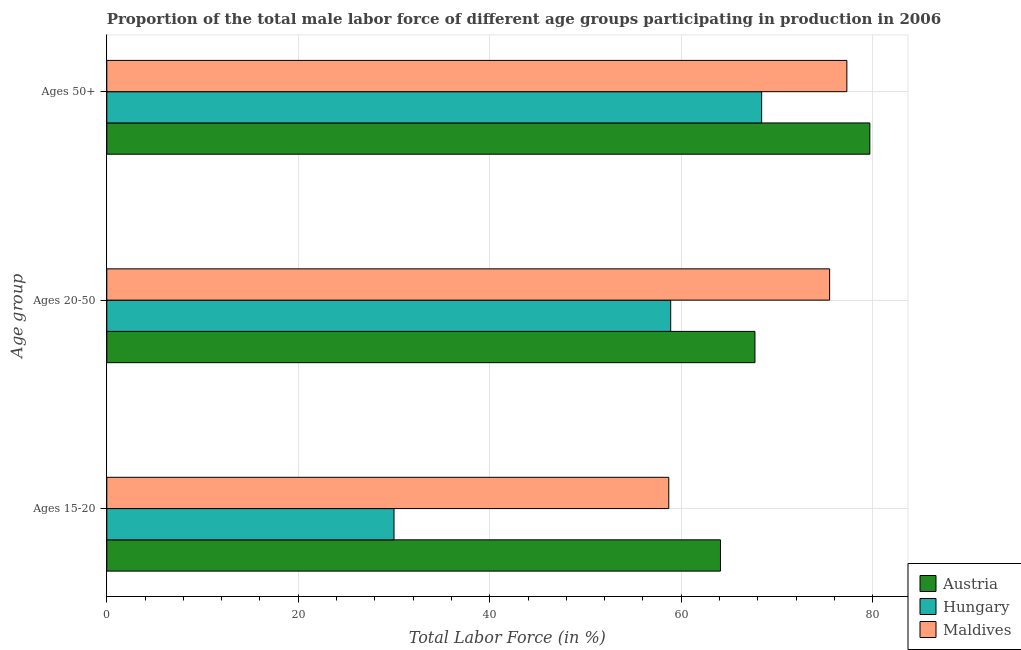How many different coloured bars are there?
Keep it short and to the point. 3. How many groups of bars are there?
Ensure brevity in your answer.  3. Are the number of bars per tick equal to the number of legend labels?
Keep it short and to the point. Yes. How many bars are there on the 1st tick from the top?
Offer a terse response. 3. How many bars are there on the 3rd tick from the bottom?
Offer a terse response. 3. What is the label of the 2nd group of bars from the top?
Provide a succinct answer. Ages 20-50. What is the percentage of male labor force within the age group 15-20 in Austria?
Offer a very short reply. 64.1. Across all countries, what is the maximum percentage of male labor force within the age group 15-20?
Keep it short and to the point. 64.1. Across all countries, what is the minimum percentage of male labor force within the age group 20-50?
Your answer should be very brief. 58.9. In which country was the percentage of male labor force within the age group 20-50 maximum?
Give a very brief answer. Maldives. In which country was the percentage of male labor force within the age group 20-50 minimum?
Ensure brevity in your answer.  Hungary. What is the total percentage of male labor force above age 50 in the graph?
Your answer should be very brief. 225.4. What is the difference between the percentage of male labor force within the age group 15-20 in Maldives and that in Hungary?
Your response must be concise. 28.7. What is the difference between the percentage of male labor force above age 50 in Hungary and the percentage of male labor force within the age group 15-20 in Austria?
Make the answer very short. 4.3. What is the average percentage of male labor force within the age group 15-20 per country?
Keep it short and to the point. 50.93. What is the difference between the percentage of male labor force within the age group 20-50 and percentage of male labor force above age 50 in Hungary?
Your answer should be compact. -9.5. In how many countries, is the percentage of male labor force within the age group 20-50 greater than 72 %?
Ensure brevity in your answer.  1. What is the ratio of the percentage of male labor force above age 50 in Maldives to that in Hungary?
Your answer should be very brief. 1.13. What is the difference between the highest and the second highest percentage of male labor force within the age group 15-20?
Offer a terse response. 5.4. What is the difference between the highest and the lowest percentage of male labor force above age 50?
Make the answer very short. 11.3. In how many countries, is the percentage of male labor force above age 50 greater than the average percentage of male labor force above age 50 taken over all countries?
Offer a terse response. 2. Is the sum of the percentage of male labor force within the age group 20-50 in Hungary and Austria greater than the maximum percentage of male labor force above age 50 across all countries?
Ensure brevity in your answer.  Yes. What does the 1st bar from the top in Ages 15-20 represents?
Provide a short and direct response. Maldives. What does the 3rd bar from the bottom in Ages 15-20 represents?
Offer a very short reply. Maldives. Does the graph contain grids?
Your response must be concise. Yes. How are the legend labels stacked?
Ensure brevity in your answer.  Vertical. What is the title of the graph?
Give a very brief answer. Proportion of the total male labor force of different age groups participating in production in 2006. Does "Liberia" appear as one of the legend labels in the graph?
Provide a succinct answer. No. What is the label or title of the Y-axis?
Offer a terse response. Age group. What is the Total Labor Force (in %) in Austria in Ages 15-20?
Offer a very short reply. 64.1. What is the Total Labor Force (in %) in Hungary in Ages 15-20?
Make the answer very short. 30. What is the Total Labor Force (in %) in Maldives in Ages 15-20?
Offer a very short reply. 58.7. What is the Total Labor Force (in %) in Austria in Ages 20-50?
Provide a succinct answer. 67.7. What is the Total Labor Force (in %) in Hungary in Ages 20-50?
Your response must be concise. 58.9. What is the Total Labor Force (in %) in Maldives in Ages 20-50?
Offer a very short reply. 75.5. What is the Total Labor Force (in %) of Austria in Ages 50+?
Make the answer very short. 79.7. What is the Total Labor Force (in %) in Hungary in Ages 50+?
Provide a short and direct response. 68.4. What is the Total Labor Force (in %) in Maldives in Ages 50+?
Ensure brevity in your answer.  77.3. Across all Age group, what is the maximum Total Labor Force (in %) of Austria?
Provide a succinct answer. 79.7. Across all Age group, what is the maximum Total Labor Force (in %) of Hungary?
Your answer should be very brief. 68.4. Across all Age group, what is the maximum Total Labor Force (in %) in Maldives?
Provide a short and direct response. 77.3. Across all Age group, what is the minimum Total Labor Force (in %) in Austria?
Your response must be concise. 64.1. Across all Age group, what is the minimum Total Labor Force (in %) of Maldives?
Keep it short and to the point. 58.7. What is the total Total Labor Force (in %) of Austria in the graph?
Your answer should be compact. 211.5. What is the total Total Labor Force (in %) in Hungary in the graph?
Your answer should be compact. 157.3. What is the total Total Labor Force (in %) of Maldives in the graph?
Give a very brief answer. 211.5. What is the difference between the Total Labor Force (in %) of Hungary in Ages 15-20 and that in Ages 20-50?
Keep it short and to the point. -28.9. What is the difference between the Total Labor Force (in %) in Maldives in Ages 15-20 and that in Ages 20-50?
Ensure brevity in your answer.  -16.8. What is the difference between the Total Labor Force (in %) in Austria in Ages 15-20 and that in Ages 50+?
Ensure brevity in your answer.  -15.6. What is the difference between the Total Labor Force (in %) of Hungary in Ages 15-20 and that in Ages 50+?
Give a very brief answer. -38.4. What is the difference between the Total Labor Force (in %) of Maldives in Ages 15-20 and that in Ages 50+?
Your answer should be very brief. -18.6. What is the difference between the Total Labor Force (in %) of Austria in Ages 15-20 and the Total Labor Force (in %) of Hungary in Ages 20-50?
Your answer should be compact. 5.2. What is the difference between the Total Labor Force (in %) in Hungary in Ages 15-20 and the Total Labor Force (in %) in Maldives in Ages 20-50?
Provide a short and direct response. -45.5. What is the difference between the Total Labor Force (in %) in Austria in Ages 15-20 and the Total Labor Force (in %) in Maldives in Ages 50+?
Provide a short and direct response. -13.2. What is the difference between the Total Labor Force (in %) of Hungary in Ages 15-20 and the Total Labor Force (in %) of Maldives in Ages 50+?
Make the answer very short. -47.3. What is the difference between the Total Labor Force (in %) of Hungary in Ages 20-50 and the Total Labor Force (in %) of Maldives in Ages 50+?
Offer a very short reply. -18.4. What is the average Total Labor Force (in %) of Austria per Age group?
Offer a terse response. 70.5. What is the average Total Labor Force (in %) of Hungary per Age group?
Offer a terse response. 52.43. What is the average Total Labor Force (in %) of Maldives per Age group?
Keep it short and to the point. 70.5. What is the difference between the Total Labor Force (in %) of Austria and Total Labor Force (in %) of Hungary in Ages 15-20?
Keep it short and to the point. 34.1. What is the difference between the Total Labor Force (in %) of Austria and Total Labor Force (in %) of Maldives in Ages 15-20?
Your answer should be compact. 5.4. What is the difference between the Total Labor Force (in %) in Hungary and Total Labor Force (in %) in Maldives in Ages 15-20?
Provide a short and direct response. -28.7. What is the difference between the Total Labor Force (in %) in Austria and Total Labor Force (in %) in Hungary in Ages 20-50?
Your answer should be very brief. 8.8. What is the difference between the Total Labor Force (in %) in Hungary and Total Labor Force (in %) in Maldives in Ages 20-50?
Your answer should be very brief. -16.6. What is the difference between the Total Labor Force (in %) of Austria and Total Labor Force (in %) of Maldives in Ages 50+?
Offer a very short reply. 2.4. What is the ratio of the Total Labor Force (in %) of Austria in Ages 15-20 to that in Ages 20-50?
Your answer should be very brief. 0.95. What is the ratio of the Total Labor Force (in %) of Hungary in Ages 15-20 to that in Ages 20-50?
Give a very brief answer. 0.51. What is the ratio of the Total Labor Force (in %) of Maldives in Ages 15-20 to that in Ages 20-50?
Your response must be concise. 0.78. What is the ratio of the Total Labor Force (in %) of Austria in Ages 15-20 to that in Ages 50+?
Offer a very short reply. 0.8. What is the ratio of the Total Labor Force (in %) of Hungary in Ages 15-20 to that in Ages 50+?
Make the answer very short. 0.44. What is the ratio of the Total Labor Force (in %) in Maldives in Ages 15-20 to that in Ages 50+?
Keep it short and to the point. 0.76. What is the ratio of the Total Labor Force (in %) of Austria in Ages 20-50 to that in Ages 50+?
Your response must be concise. 0.85. What is the ratio of the Total Labor Force (in %) in Hungary in Ages 20-50 to that in Ages 50+?
Give a very brief answer. 0.86. What is the ratio of the Total Labor Force (in %) in Maldives in Ages 20-50 to that in Ages 50+?
Your answer should be compact. 0.98. What is the difference between the highest and the second highest Total Labor Force (in %) of Austria?
Give a very brief answer. 12. What is the difference between the highest and the lowest Total Labor Force (in %) of Hungary?
Provide a short and direct response. 38.4. What is the difference between the highest and the lowest Total Labor Force (in %) of Maldives?
Your answer should be very brief. 18.6. 